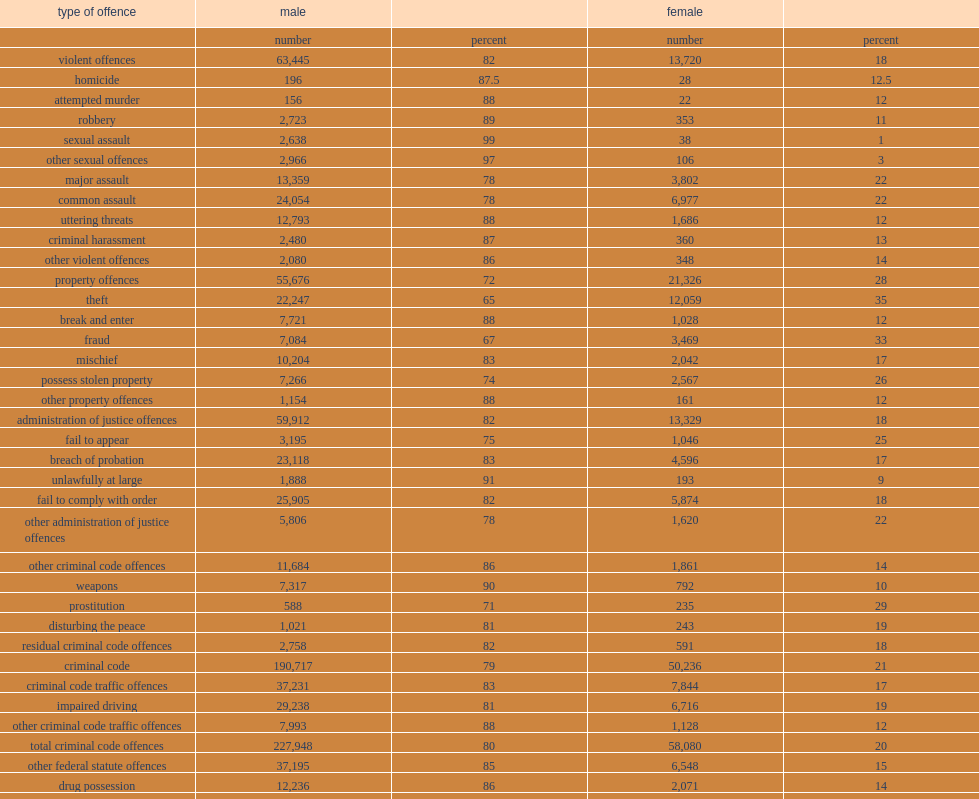What is the proportion of male of accused persons in adult criminal courts? 80.0. What is the proportion of female of accused persons in adult criminal courts? 20.0. What is the proportion of male defendants in violent crimes such as sexual assault? 99.0. What is the proportion of male defendants in violent crimes such as other sexual offences? 97.0. What is the proportion of male defendants in violent crimes such as robbery? 89.0. When female defendants appear in court, what is the proportion of theft? 35.0. When female defendants appear in court, what is the proportion of fraud? 33.0. 